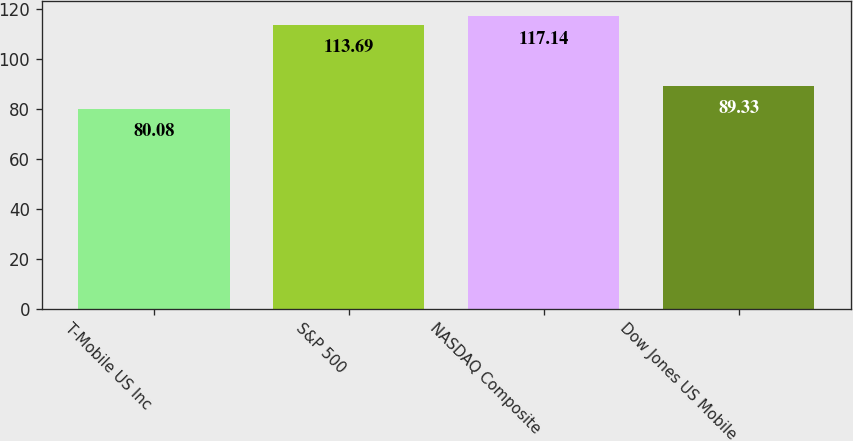Convert chart to OTSL. <chart><loc_0><loc_0><loc_500><loc_500><bar_chart><fcel>T-Mobile US Inc<fcel>S&P 500<fcel>NASDAQ Composite<fcel>Dow Jones US Mobile<nl><fcel>80.08<fcel>113.69<fcel>117.14<fcel>89.33<nl></chart> 